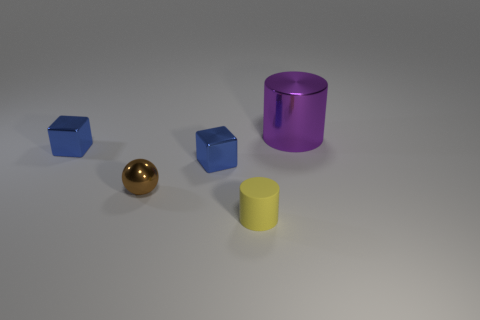How many large purple metallic things are on the left side of the cylinder that is behind the yellow matte cylinder?
Your response must be concise. 0. How many rubber things are either brown spheres or yellow cylinders?
Keep it short and to the point. 1. Is there a blue cube that has the same material as the big cylinder?
Your response must be concise. Yes. How many things are blocks that are right of the small metal sphere or objects that are right of the small yellow matte cylinder?
Provide a short and direct response. 2. What number of other things are the same color as the metal cylinder?
Give a very brief answer. 0. What material is the tiny yellow object?
Offer a terse response. Rubber. Is the size of the thing that is in front of the ball the same as the purple metal object?
Ensure brevity in your answer.  No. Is there anything else that has the same size as the purple thing?
Provide a succinct answer. No. The other matte object that is the same shape as the large purple thing is what size?
Your answer should be very brief. Small. Are there the same number of large purple metallic cylinders behind the tiny sphere and purple metal cylinders on the left side of the big purple shiny cylinder?
Provide a short and direct response. No. 